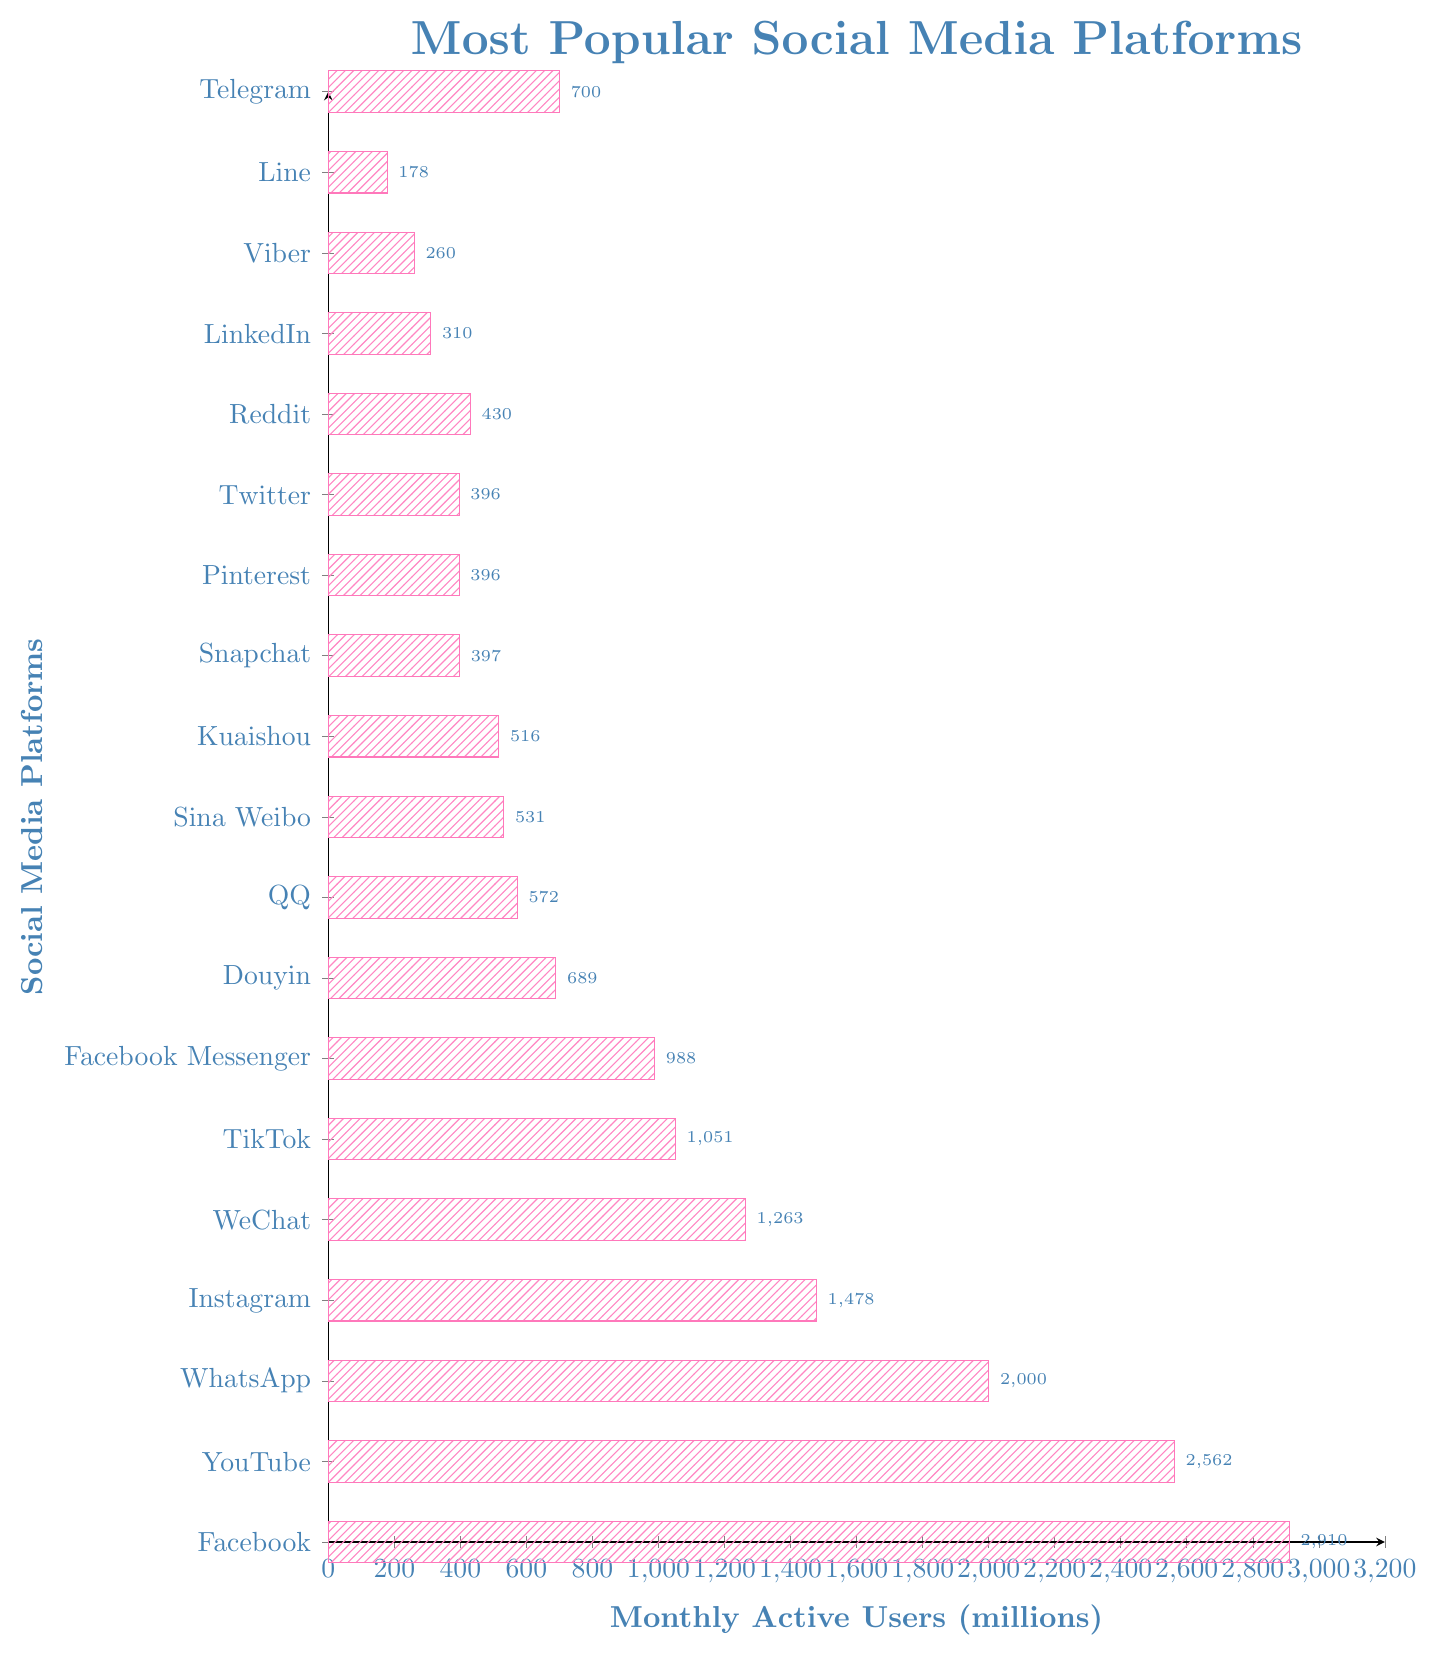What platform has the highest number of monthly active users? By examining the lengths of the bars, the bar that extends the furthest to the right corresponds to Facebook, which has the highest number of monthly active users.
Answer: Facebook How many more users does Facebook have compared to Instagram? According to the chart, Facebook has 2910 million users and Instagram has 1478 million users. The difference is calculated as 2910 - 1478 = 1432 million users.
Answer: 1432 million Which platform has a greater number of monthly active users, WhatsApp or TikTok? From the chart, WhatsApp has a longer bar representing 2000 million users, while TikTok has 1051 million users, indicating WhatsApp has more users.
Answer: WhatsApp What is the total number of monthly active users for YouTube and WhatsApp combined? YouTube has 2562 million users and WhatsApp has 2000 million users. Together, they make 2562 + 2000 = 4562 million users.
Answer: 4562 million How many platforms have more than 1000 million monthly active users? By inspecting the chart, the platforms exceeding 1000 million users are: Facebook, YouTube, WhatsApp, Instagram, WeChat, and TikTok, totaling 6 platforms.
Answer: 6 platforms What is the difference in monthly active users between the platform with the least and the third least users? From the chart, Viber has the least with 260 million users, and Line has the third least with 310 million users. The difference is 310 - 260 = 50 million users.
Answer: 50 million Which platform is ranked fifth in terms of monthly active users? By looking at the order of the bars from longest to shortest, the fifth platform is WeChat with 1263 million users.
Answer: WeChat Which two platforms have almost equal monthly active users? From the chart, Pinterest (396 million users) and Twitter (396 million users) have almost the same number of users.
Answer: Pinterest and Twitter What is the combined number of monthly active users for Douyin, QQ, and Sina Weibo? Douyin has 689 million users, QQ has 572 million users, and Sina Weibo has 531 million users. Their combined total is 689 + 572 + 531 = 1792 million users.
Answer: 1792 million Which platform is directly below Telegram in terms of monthly active users? According to the chart, Telegram has 700 million users, and directly below it is Douyin with 689 million users.
Answer: Douyin 